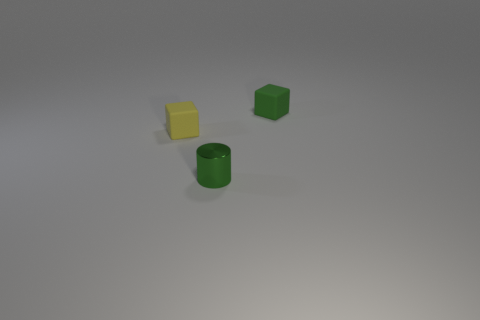Is there anything else that is the same material as the cylinder?
Provide a succinct answer. No. Are there fewer small objects that are in front of the yellow object than small cubes?
Keep it short and to the point. Yes. What number of small objects are in front of the tiny yellow object?
Ensure brevity in your answer.  1. Does the tiny yellow matte object that is in front of the green matte cube have the same shape as the small object that is on the right side of the small green metal cylinder?
Offer a very short reply. Yes. There is a tiny object that is behind the small green cylinder and right of the tiny yellow object; what shape is it?
Provide a short and direct response. Cube. There is a green thing that is the same material as the small yellow object; what size is it?
Keep it short and to the point. Small. Are there fewer small matte things than green metal objects?
Give a very brief answer. No. What material is the green object in front of the tiny rubber thing on the left side of the rubber block that is right of the tiny yellow thing?
Provide a short and direct response. Metal. Is the material of the tiny green object that is on the right side of the small shiny object the same as the small green thing that is in front of the yellow rubber cube?
Offer a terse response. No. There is a object that is behind the cylinder and on the left side of the green rubber thing; how big is it?
Ensure brevity in your answer.  Small. 